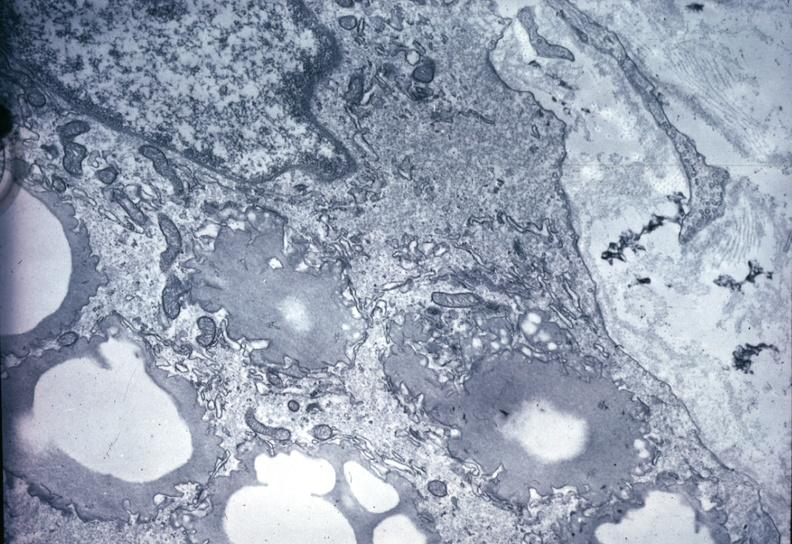what is present?
Answer the question using a single word or phrase. Artery 